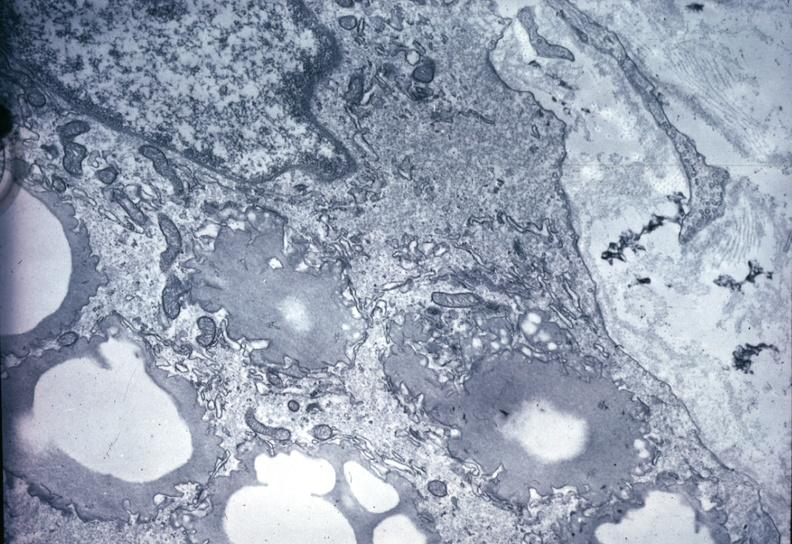what is present?
Answer the question using a single word or phrase. Artery 